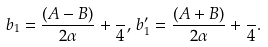Convert formula to latex. <formula><loc_0><loc_0><loc_500><loc_500>b _ { 1 } = \frac { ( A - B ) } { 2 \alpha } + \frac { } { 4 } , \, b _ { 1 } ^ { \prime } = \frac { ( A + B ) } { 2 \alpha } + \frac { } { 4 } .</formula> 